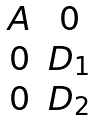Convert formula to latex. <formula><loc_0><loc_0><loc_500><loc_500>\begin{matrix} A & 0 \\ 0 & D _ { 1 } \\ 0 & D _ { 2 } \end{matrix}</formula> 